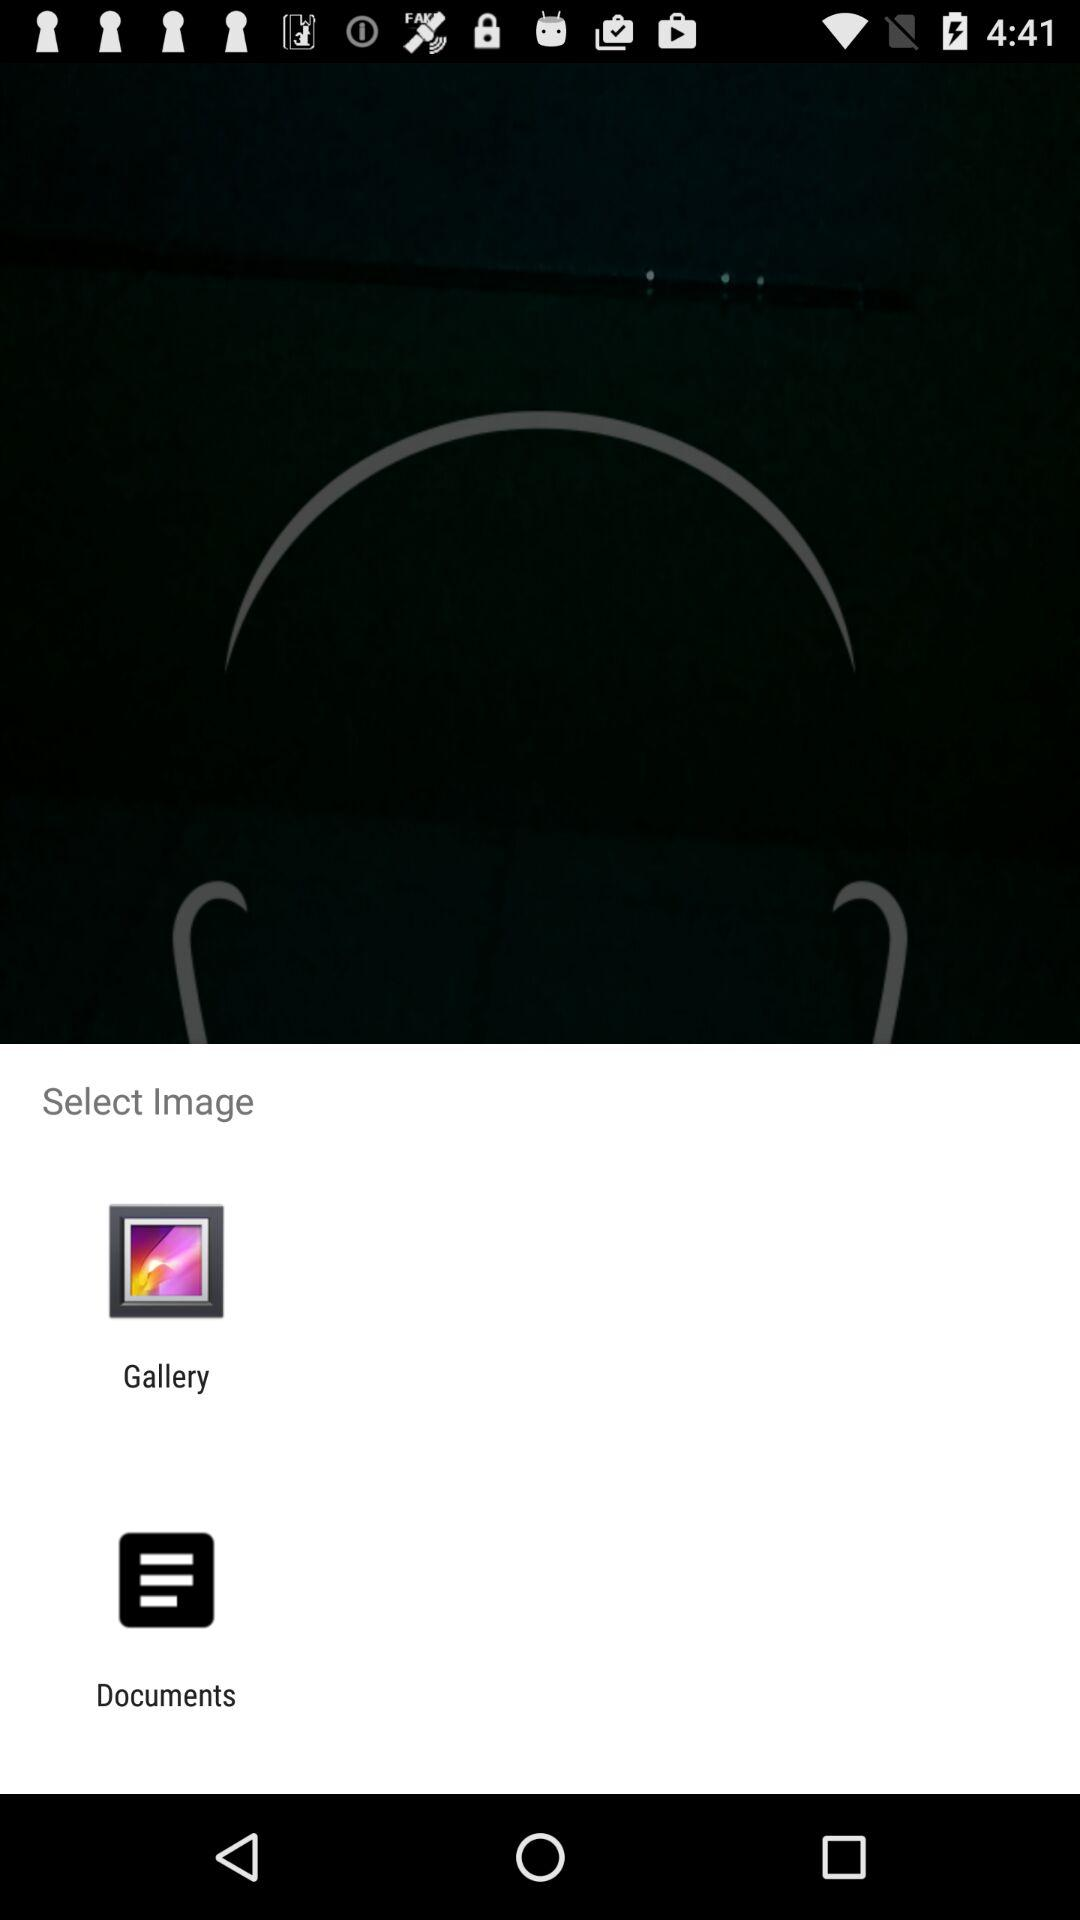Which are the options to select the image with? The options are "Gallery" and "Documents". 